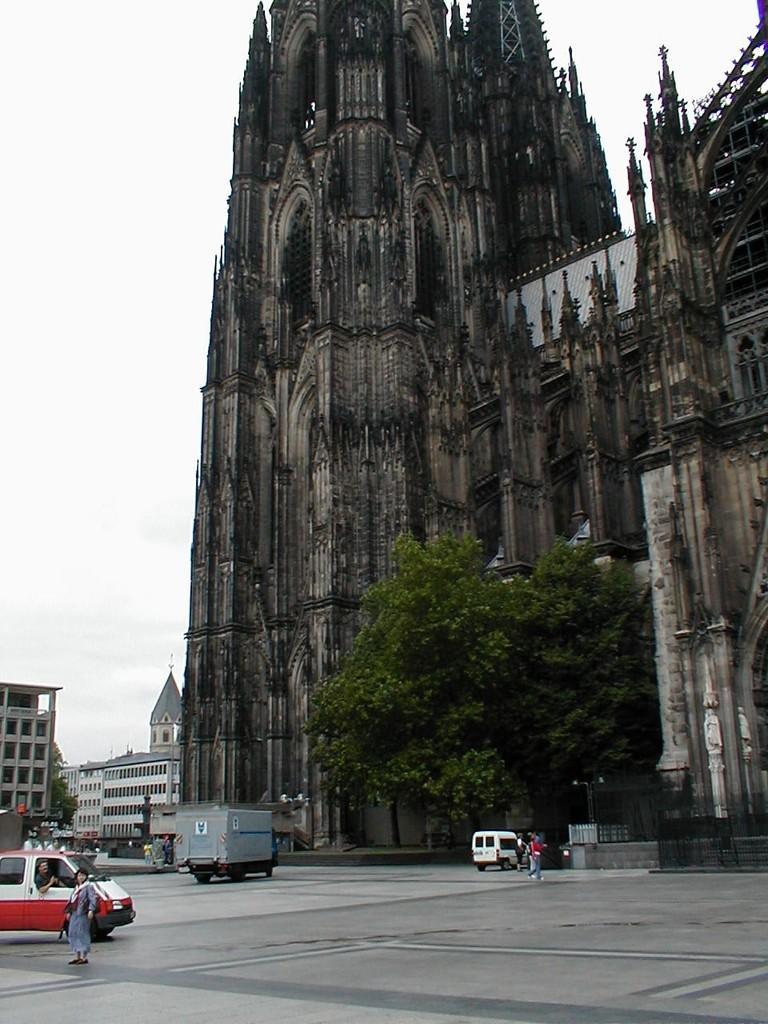Describe this image in one or two sentences. In the foreground of the picture there are vehicles, people and road. In the middle of the picture we can see buildings, trees, cathedral and various other object. At the top there is sky. 